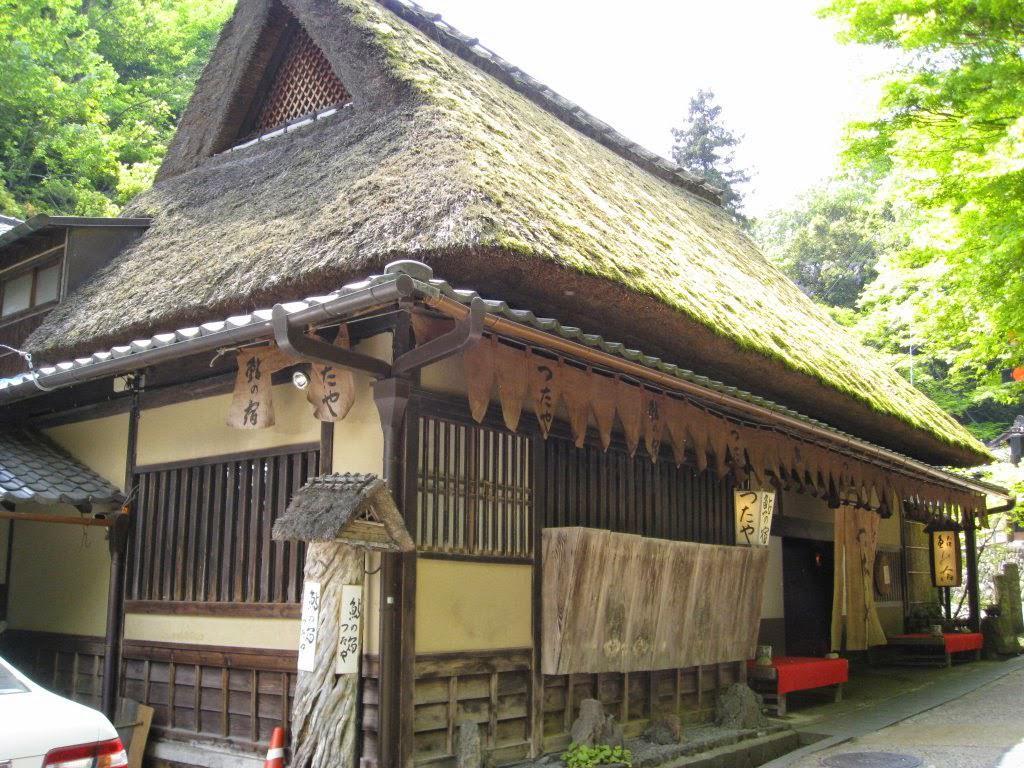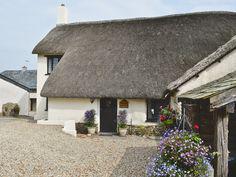The first image is the image on the left, the second image is the image on the right. For the images displayed, is the sentence "Both of the structures are enclosed" factually correct? Answer yes or no. Yes. The first image is the image on the left, the second image is the image on the right. For the images shown, is this caption "The right image shows a non-tiered thatch roof over an open-sided structure with square columns in the corners." true? Answer yes or no. No. 